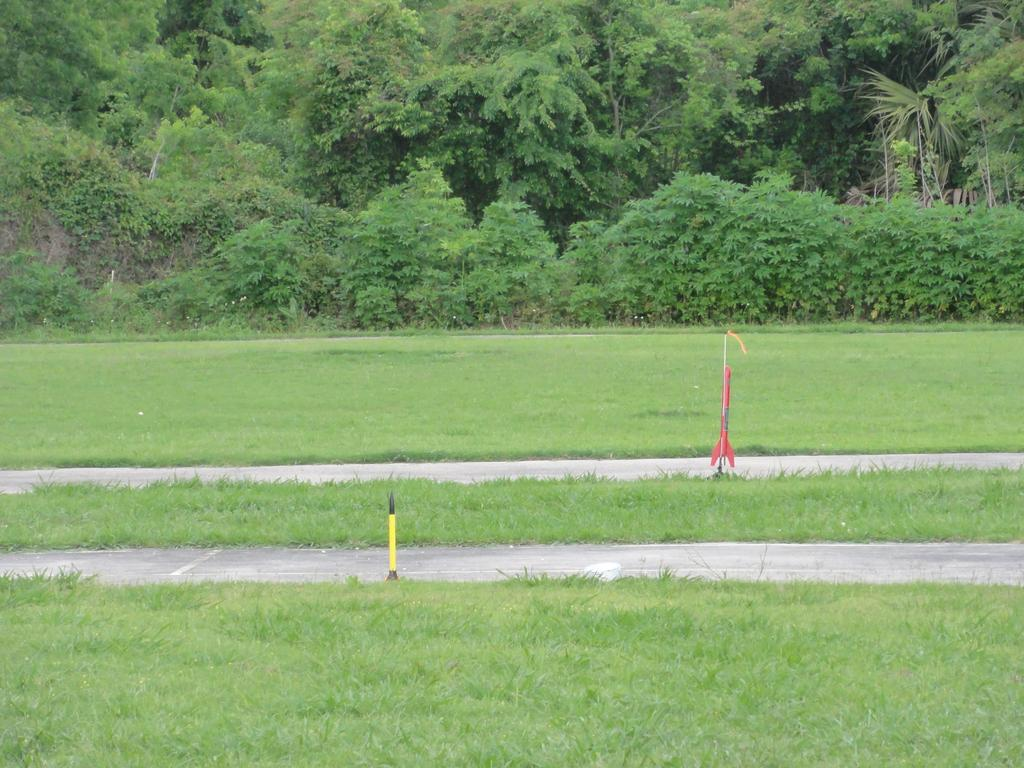What type of vegetation is visible in the image? There is grass in the image. What structures can be seen in the image? There are poles in the image. What can be seen in the background of the image? There are trees in the background of the image. Is there any quicksand visible in the image? No, there is no quicksand present in the image. What type of sponge can be seen absorbing water in the image? There is no sponge present in the image. 